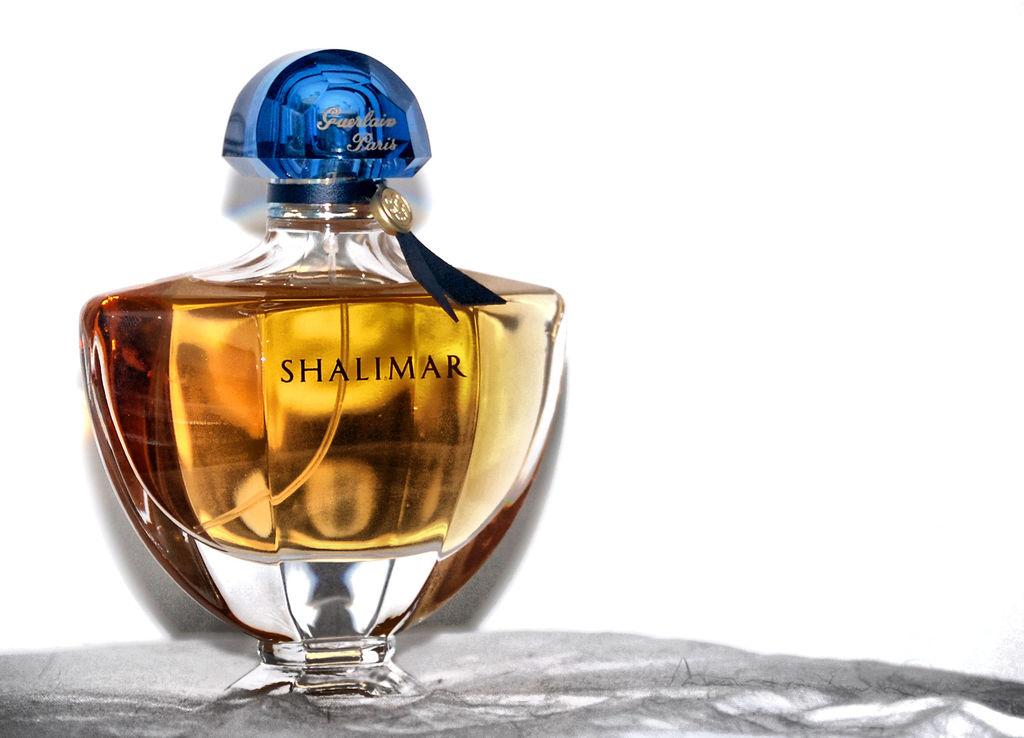<image>
Give a short and clear explanation of the subsequent image. A bottle of the perfume Shalimar has a blue top. 